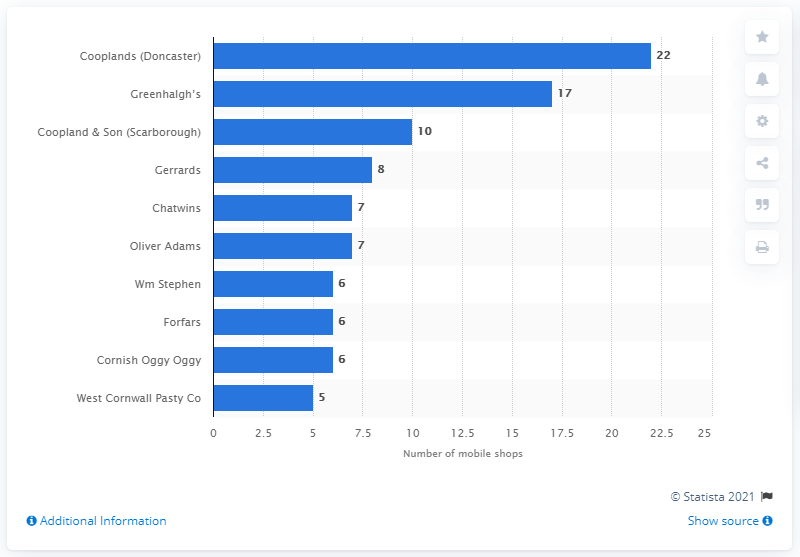Specify some key components in this picture. In 2013, Cooplands, a mobile operator based in Doncaster, was the highest ranking mobile operator in the industry. 